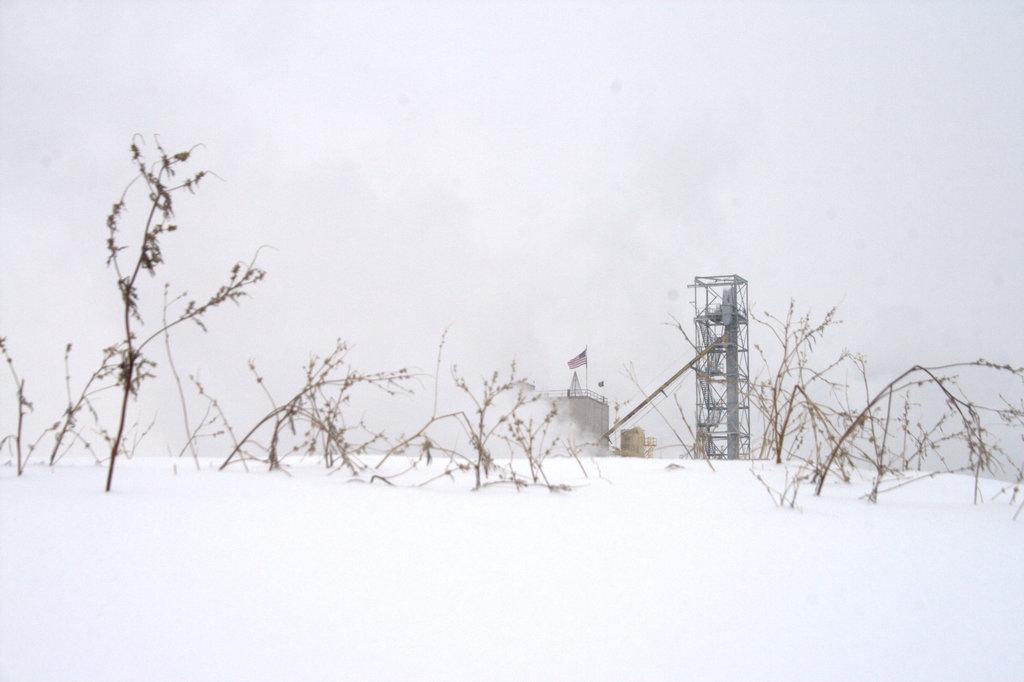In one or two sentences, can you explain what this image depicts? On the right side of the image there is a tower and a building we can see a flag. At the bottom there are plants and snow. In the background there is sky. 